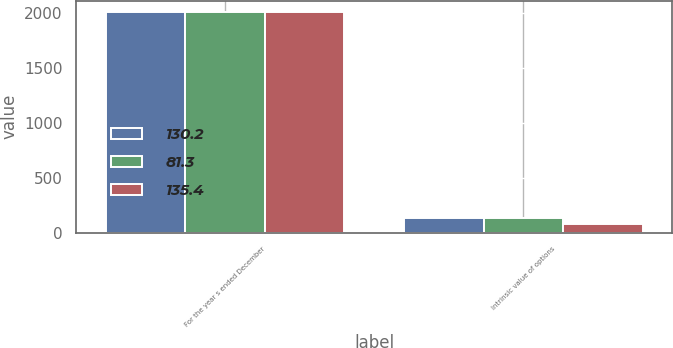Convert chart. <chart><loc_0><loc_0><loc_500><loc_500><stacked_bar_chart><ecel><fcel>For the year s ended December<fcel>Intrinsic value of options<nl><fcel>130.2<fcel>2013<fcel>135.4<nl><fcel>81.3<fcel>2012<fcel>130.2<nl><fcel>135.4<fcel>2011<fcel>81.3<nl></chart> 